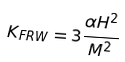<formula> <loc_0><loc_0><loc_500><loc_500>K _ { F R W } = 3 \frac { \alpha H ^ { 2 } } { M ^ { 2 } }</formula> 